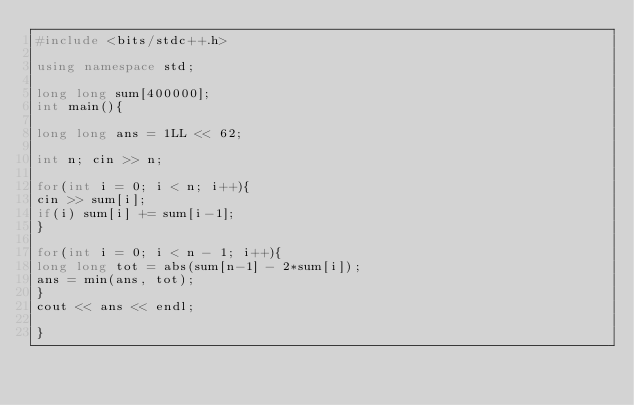<code> <loc_0><loc_0><loc_500><loc_500><_C++_>#include <bits/stdc++.h>
 
using namespace std;
 
long long sum[400000];
int main(){
 
long long ans = 1LL << 62;
 
int n; cin >> n;
 
for(int i = 0; i < n; i++){
cin >> sum[i];
if(i) sum[i] += sum[i-1];
}
 
for(int i = 0; i < n - 1; i++){
long long tot = abs(sum[n-1] - 2*sum[i]);
ans = min(ans, tot);
}
cout << ans << endl;
 
}</code> 